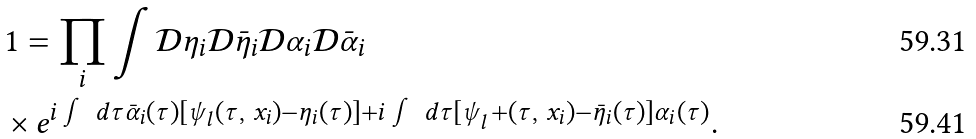<formula> <loc_0><loc_0><loc_500><loc_500>& 1 = \prod _ { i } \int \mathcal { D } \eta _ { i } \mathcal { D } \bar { \eta } _ { i } \mathcal { D } \alpha _ { i } \mathcal { D } \bar { \alpha } _ { i } \\ & \times e ^ { i \int \, d \tau \bar { \alpha } _ { i } ( \tau ) [ \psi _ { l } ( \tau , \ x _ { i } ) - \eta _ { i } ( \tau ) ] + i \int \, d \tau [ \psi _ { l } ^ { \ } + ( \tau , \ x _ { i } ) - \bar { \eta } _ { i } ( \tau ) ] \alpha _ { i } ( \tau ) } .</formula> 